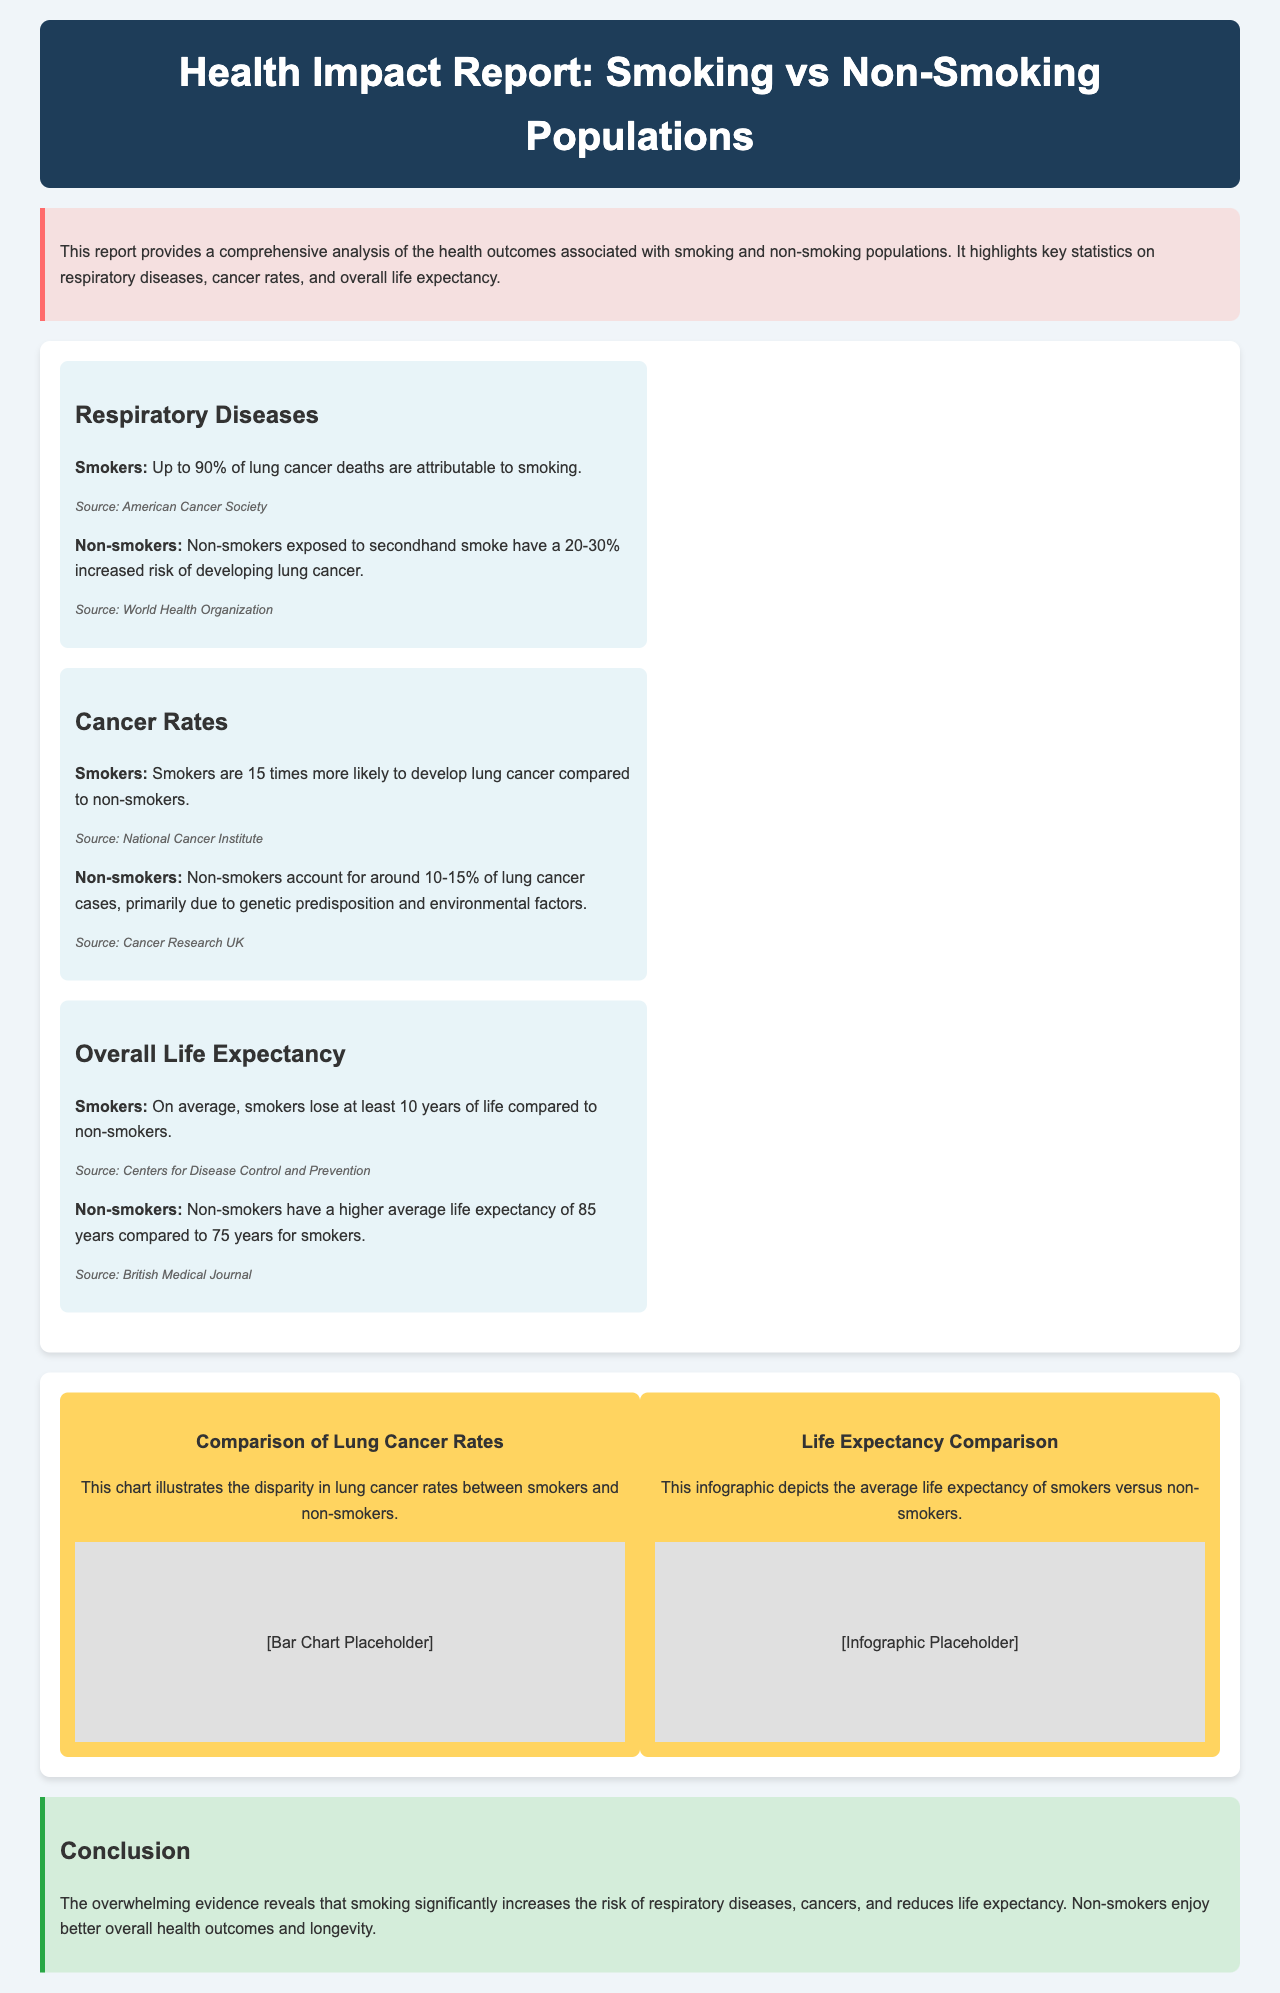What percentage of lung cancer deaths are attributable to smoking? The document states that up to 90% of lung cancer deaths are attributable to smoking.
Answer: 90% How much more likely are smokers to develop lung cancer compared to non-smokers? The report indicates that smokers are 15 times more likely to develop lung cancer than non-smokers.
Answer: 15 times What is the average life expectancy for non-smokers according to the report? The document mentions that non-smokers have an average life expectancy of 85 years.
Answer: 85 years What is the life expectancy difference between smokers and non-smokers? Smokers lose at least 10 years of life compared to non-smokers, leading to a life expectancy difference of 10 years.
Answer: 10 years What percentage of lung cancer cases do non-smokers account for? According to the report, non-smokers account for around 10-15% of lung cancer cases.
Answer: 10-15% What health issue is predominantly linked to secondhand smoke for non-smokers? The document states that non-smokers exposed to secondhand smoke have a significant risk of developing lung cancer.
Answer: Lung cancer Which organization reports that smokers are more likely to develop lung cancer? The National Cancer Institute is cited as the source stating that smokers are more likely to develop lung cancer.
Answer: National Cancer Institute What primary cause of lung cancer deaths is highlighted in the report? The report emphasizes that smoking is the primary cause linked to lung cancer deaths.
Answer: Smoking 